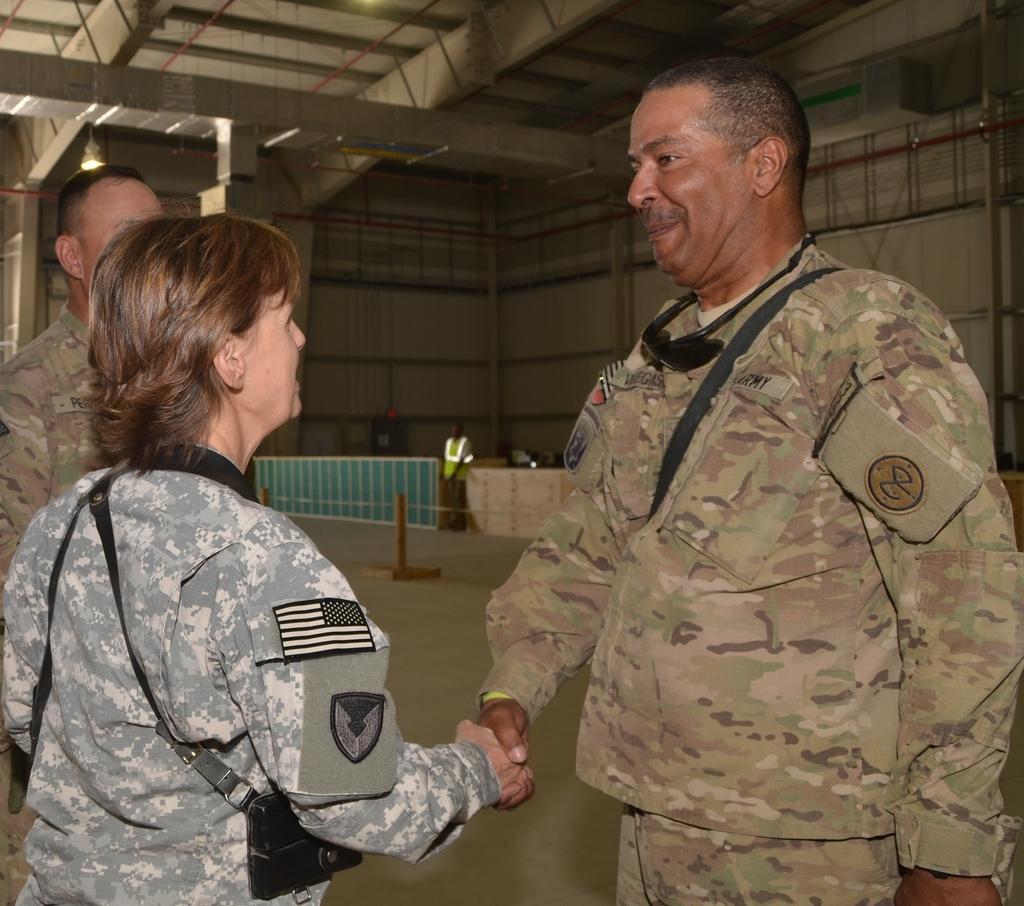Describe this image in one or two sentences. In this picture there is a two male military officer and a lady officer shaking the hand. Behind there is a metal frame and green color fencing grill. 